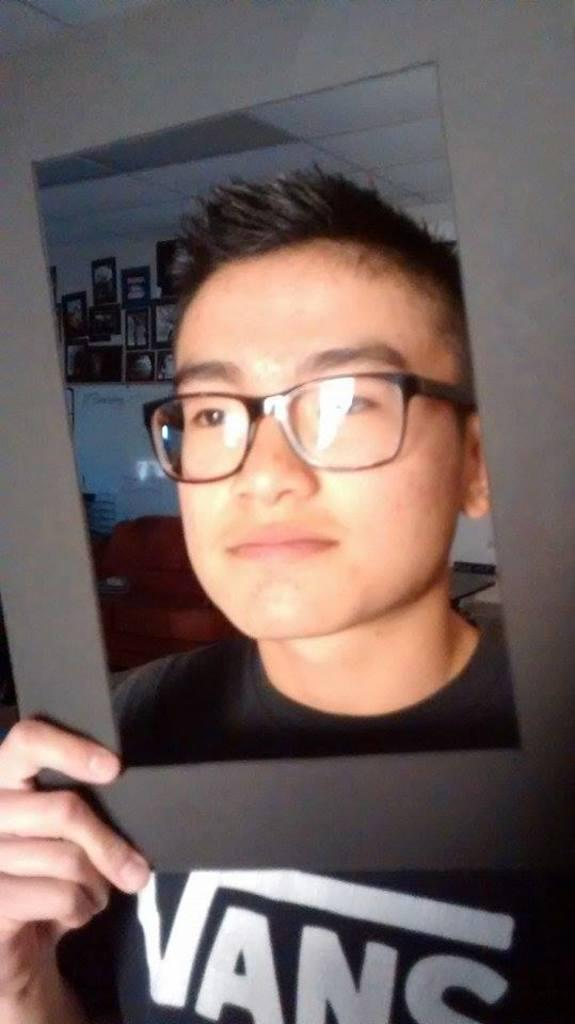What can be seen in the image? There is a person in the image. What is the person holding? The person is holding an object. What is located behind the person? There is a whiteboard behind the person. What can be observed on the wall in the image? There are many photos on the wall. What type of cork is being used to write on the whiteboard? There is no cork visible in the image, and the whiteboard is not being written on. 